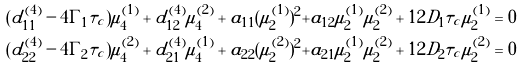Convert formula to latex. <formula><loc_0><loc_0><loc_500><loc_500>( d ^ { ( 4 ) } _ { 1 1 } - 4 \Gamma _ { 1 } \tau _ { c } ) \mu ^ { ( 1 ) } _ { 4 } + d ^ { ( 4 ) } _ { 1 2 } \mu ^ { ( 2 ) } _ { 4 } + a _ { 1 1 } ( \mu ^ { ( 1 ) } _ { 2 } ) ^ { 2 } + a _ { 1 2 } \mu ^ { ( 1 ) } _ { 2 } \mu ^ { ( 2 ) } _ { 2 } + 1 2 D _ { 1 } \tau _ { c } \mu ^ { ( 1 ) } _ { 2 } & = 0 \\ ( d ^ { ( 4 ) } _ { 2 2 } - 4 \Gamma _ { 2 } \tau _ { c } ) \mu ^ { ( 2 ) } _ { 4 } + d ^ { ( 4 ) } _ { 2 1 } \mu ^ { ( 1 ) } _ { 4 } + a _ { 2 2 } ( \mu ^ { ( 2 ) } _ { 2 } ) ^ { 2 } + a _ { 2 1 } \mu ^ { ( 1 ) } _ { 2 } \mu ^ { ( 2 ) } _ { 2 } + 1 2 D _ { 2 } \tau _ { c } \mu ^ { ( 2 ) } _ { 2 } & = 0</formula> 